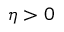<formula> <loc_0><loc_0><loc_500><loc_500>\eta > 0</formula> 